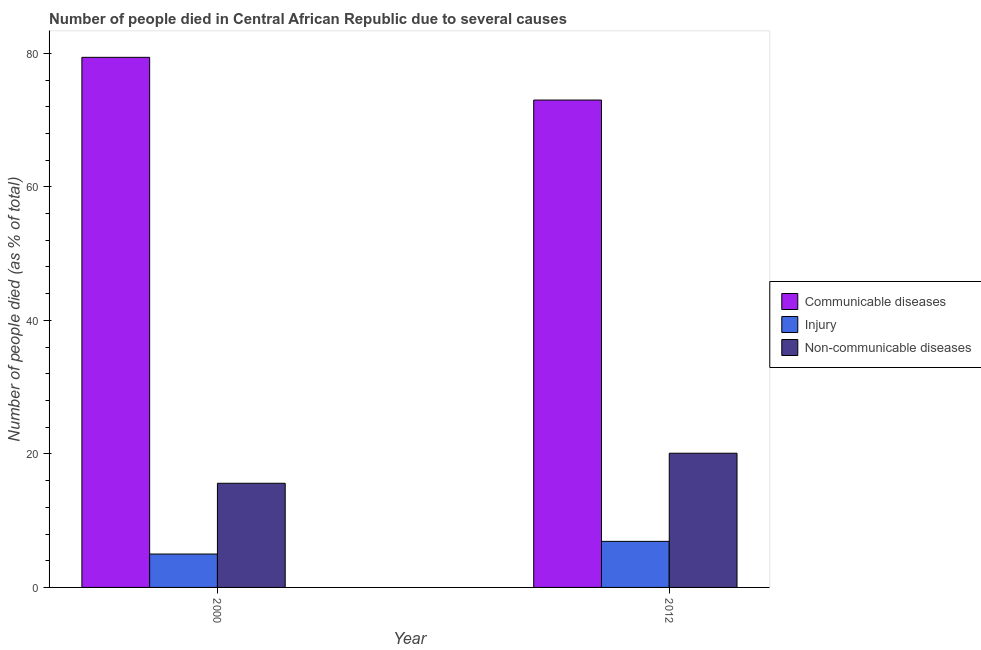How many different coloured bars are there?
Provide a succinct answer. 3. How many groups of bars are there?
Ensure brevity in your answer.  2. How many bars are there on the 2nd tick from the right?
Offer a very short reply. 3. What is the label of the 2nd group of bars from the left?
Your answer should be very brief. 2012. What is the number of people who dies of non-communicable diseases in 2012?
Provide a short and direct response. 20.1. Across all years, what is the maximum number of people who dies of non-communicable diseases?
Keep it short and to the point. 20.1. Across all years, what is the minimum number of people who dies of non-communicable diseases?
Ensure brevity in your answer.  15.6. In which year was the number of people who died of injury maximum?
Ensure brevity in your answer.  2012. What is the total number of people who dies of non-communicable diseases in the graph?
Offer a terse response. 35.7. What is the difference between the number of people who died of injury in 2000 and that in 2012?
Ensure brevity in your answer.  -1.9. What is the difference between the number of people who dies of non-communicable diseases in 2000 and the number of people who died of injury in 2012?
Make the answer very short. -4.5. What is the average number of people who died of injury per year?
Your response must be concise. 5.95. In the year 2000, what is the difference between the number of people who died of communicable diseases and number of people who died of injury?
Keep it short and to the point. 0. What is the ratio of the number of people who died of injury in 2000 to that in 2012?
Offer a very short reply. 0.72. Is the number of people who died of injury in 2000 less than that in 2012?
Your answer should be compact. Yes. What does the 2nd bar from the left in 2012 represents?
Provide a succinct answer. Injury. What does the 1st bar from the right in 2000 represents?
Provide a short and direct response. Non-communicable diseases. Is it the case that in every year, the sum of the number of people who died of communicable diseases and number of people who died of injury is greater than the number of people who dies of non-communicable diseases?
Provide a short and direct response. Yes. How many bars are there?
Provide a succinct answer. 6. What is the difference between two consecutive major ticks on the Y-axis?
Make the answer very short. 20. Are the values on the major ticks of Y-axis written in scientific E-notation?
Ensure brevity in your answer.  No. Does the graph contain grids?
Your answer should be very brief. No. How many legend labels are there?
Provide a succinct answer. 3. What is the title of the graph?
Provide a short and direct response. Number of people died in Central African Republic due to several causes. What is the label or title of the X-axis?
Your response must be concise. Year. What is the label or title of the Y-axis?
Keep it short and to the point. Number of people died (as % of total). What is the Number of people died (as % of total) in Communicable diseases in 2000?
Offer a terse response. 79.4. What is the Number of people died (as % of total) of Non-communicable diseases in 2012?
Keep it short and to the point. 20.1. Across all years, what is the maximum Number of people died (as % of total) of Communicable diseases?
Keep it short and to the point. 79.4. Across all years, what is the maximum Number of people died (as % of total) in Non-communicable diseases?
Your answer should be very brief. 20.1. What is the total Number of people died (as % of total) in Communicable diseases in the graph?
Keep it short and to the point. 152.4. What is the total Number of people died (as % of total) in Non-communicable diseases in the graph?
Your answer should be very brief. 35.7. What is the difference between the Number of people died (as % of total) in Communicable diseases in 2000 and that in 2012?
Your answer should be compact. 6.4. What is the difference between the Number of people died (as % of total) of Non-communicable diseases in 2000 and that in 2012?
Keep it short and to the point. -4.5. What is the difference between the Number of people died (as % of total) in Communicable diseases in 2000 and the Number of people died (as % of total) in Injury in 2012?
Your response must be concise. 72.5. What is the difference between the Number of people died (as % of total) in Communicable diseases in 2000 and the Number of people died (as % of total) in Non-communicable diseases in 2012?
Offer a very short reply. 59.3. What is the difference between the Number of people died (as % of total) of Injury in 2000 and the Number of people died (as % of total) of Non-communicable diseases in 2012?
Ensure brevity in your answer.  -15.1. What is the average Number of people died (as % of total) of Communicable diseases per year?
Ensure brevity in your answer.  76.2. What is the average Number of people died (as % of total) in Injury per year?
Ensure brevity in your answer.  5.95. What is the average Number of people died (as % of total) of Non-communicable diseases per year?
Offer a terse response. 17.85. In the year 2000, what is the difference between the Number of people died (as % of total) of Communicable diseases and Number of people died (as % of total) of Injury?
Offer a very short reply. 74.4. In the year 2000, what is the difference between the Number of people died (as % of total) in Communicable diseases and Number of people died (as % of total) in Non-communicable diseases?
Offer a very short reply. 63.8. In the year 2012, what is the difference between the Number of people died (as % of total) in Communicable diseases and Number of people died (as % of total) in Injury?
Make the answer very short. 66.1. In the year 2012, what is the difference between the Number of people died (as % of total) of Communicable diseases and Number of people died (as % of total) of Non-communicable diseases?
Provide a succinct answer. 52.9. What is the ratio of the Number of people died (as % of total) in Communicable diseases in 2000 to that in 2012?
Offer a terse response. 1.09. What is the ratio of the Number of people died (as % of total) in Injury in 2000 to that in 2012?
Keep it short and to the point. 0.72. What is the ratio of the Number of people died (as % of total) in Non-communicable diseases in 2000 to that in 2012?
Make the answer very short. 0.78. What is the difference between the highest and the second highest Number of people died (as % of total) in Communicable diseases?
Keep it short and to the point. 6.4. What is the difference between the highest and the second highest Number of people died (as % of total) in Injury?
Offer a very short reply. 1.9. What is the difference between the highest and the lowest Number of people died (as % of total) of Communicable diseases?
Keep it short and to the point. 6.4. What is the difference between the highest and the lowest Number of people died (as % of total) in Injury?
Make the answer very short. 1.9. 